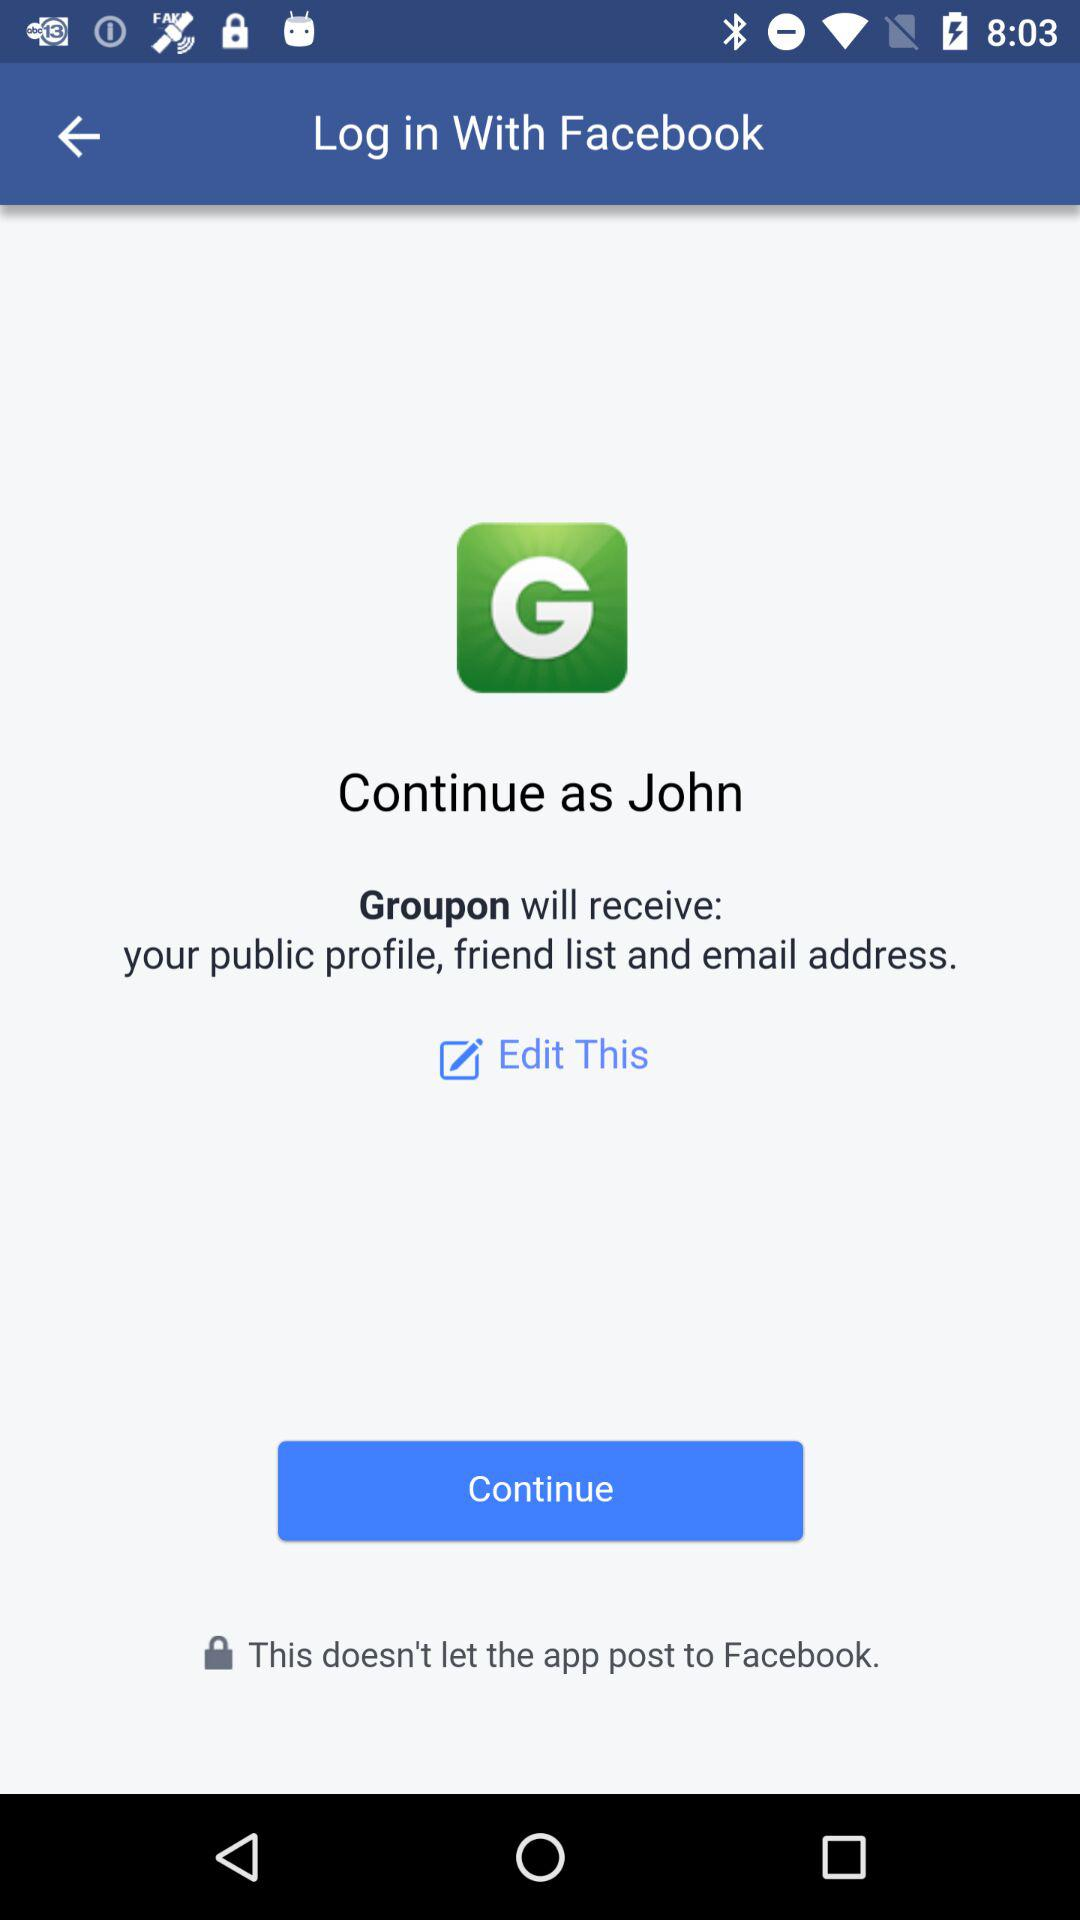Which information will "Groupon" receive? "Groupon" will receive your public profile, friend list and email address. 